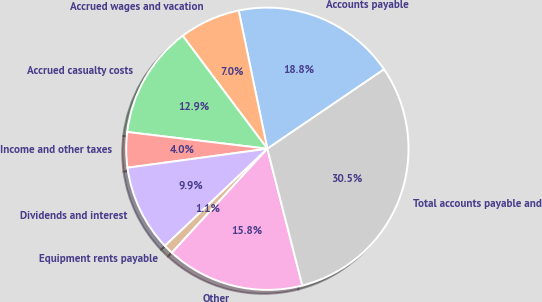Convert chart to OTSL. <chart><loc_0><loc_0><loc_500><loc_500><pie_chart><fcel>Accounts payable<fcel>Accrued wages and vacation<fcel>Accrued casualty costs<fcel>Income and other taxes<fcel>Dividends and interest<fcel>Equipment rents payable<fcel>Other<fcel>Total accounts payable and<nl><fcel>18.75%<fcel>6.98%<fcel>12.87%<fcel>4.04%<fcel>9.93%<fcel>1.1%<fcel>15.81%<fcel>30.52%<nl></chart> 